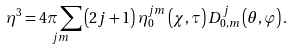Convert formula to latex. <formula><loc_0><loc_0><loc_500><loc_500>\eta ^ { 3 } = \underset { j m } { 4 \pi \sum } \left ( 2 j + 1 \right ) \eta _ { 0 } ^ { j m } \left ( \chi , \tau \right ) D _ { 0 , m } ^ { j } \left ( \theta , \varphi \right ) .</formula> 